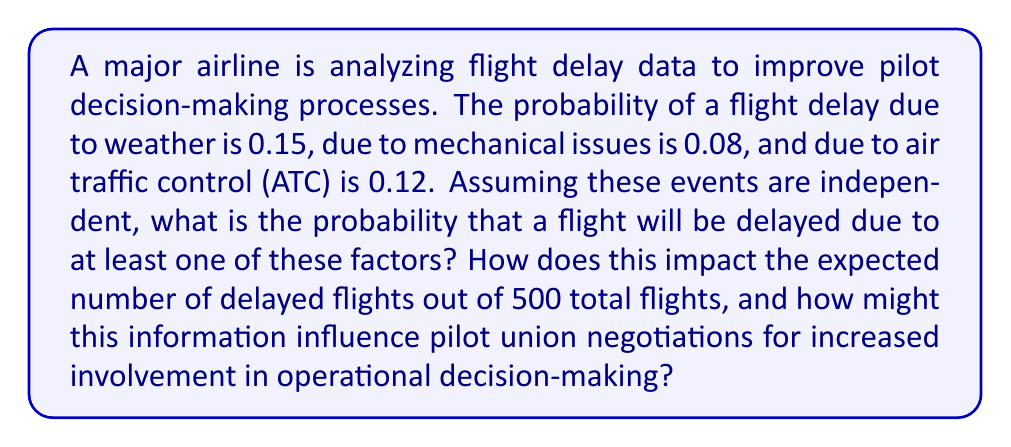Help me with this question. Let's approach this step-by-step:

1) First, we need to calculate the probability of at least one delay factor occurring. It's easier to calculate the probability of no delays and then subtract from 1.

2) Probability of no weather delay: $1 - 0.15 = 0.85$
   Probability of no mechanical delay: $1 - 0.08 = 0.92$
   Probability of no ATC delay: $1 - 0.12 = 0.88$

3) Probability of no delays at all: $0.85 \times 0.92 \times 0.88 = 0.6877$

4) Therefore, probability of at least one delay:
   $$1 - 0.6877 = 0.3123 \text{ or } 31.23\%$$

5) Expected number of delayed flights out of 500:
   $$500 \times 0.3123 = 156.15 \text{ flights}$$

6) Impact on pilot union negotiations:
   This high probability of delays (31.23%) and the expected number of delayed flights (156 out of 500) could be used by the pilot union to argue for:
   a) Increased pilot involvement in weather-related decision-making
   b) More input on maintenance schedules to reduce mechanical delays
   c) Greater collaboration with ATC for optimized flight planning

   By demonstrating how frequently delays occur and how many flights are affected, pilots can argue that their expertise and real-time decision-making skills are crucial in mitigating these delays and improving overall operational efficiency.
Answer: 0.3123 or 31.23%; 156.15 expected delayed flights out of 500 